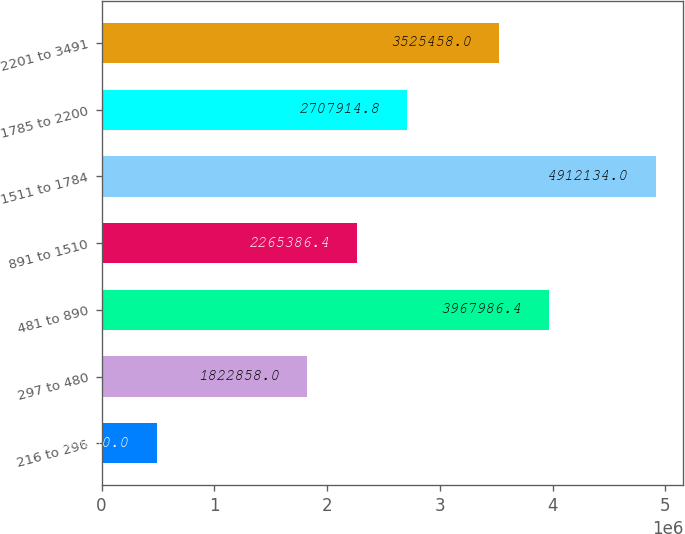Convert chart. <chart><loc_0><loc_0><loc_500><loc_500><bar_chart><fcel>216 to 296<fcel>297 to 480<fcel>481 to 890<fcel>891 to 1510<fcel>1511 to 1784<fcel>1785 to 2200<fcel>2201 to 3491<nl><fcel>486850<fcel>1.82286e+06<fcel>3.96799e+06<fcel>2.26539e+06<fcel>4.91213e+06<fcel>2.70791e+06<fcel>3.52546e+06<nl></chart> 